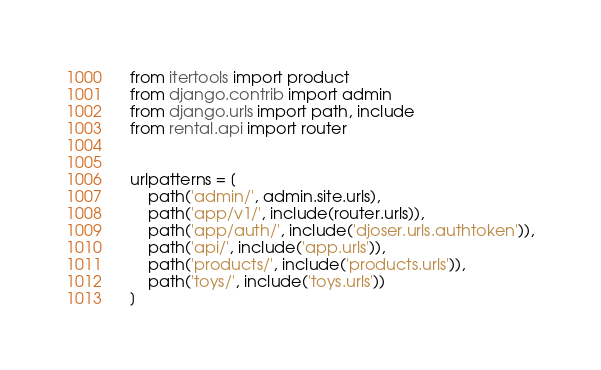Convert code to text. <code><loc_0><loc_0><loc_500><loc_500><_Python_>from itertools import product
from django.contrib import admin
from django.urls import path, include
from rental.api import router


urlpatterns = [
    path('admin/', admin.site.urls),
    path('app/v1/', include(router.urls)),
    path('app/auth/', include('djoser.urls.authtoken')),
    path('api/', include('app.urls')),
    path('products/', include('products.urls')),
    path('toys/', include('toys.urls'))
]
</code> 